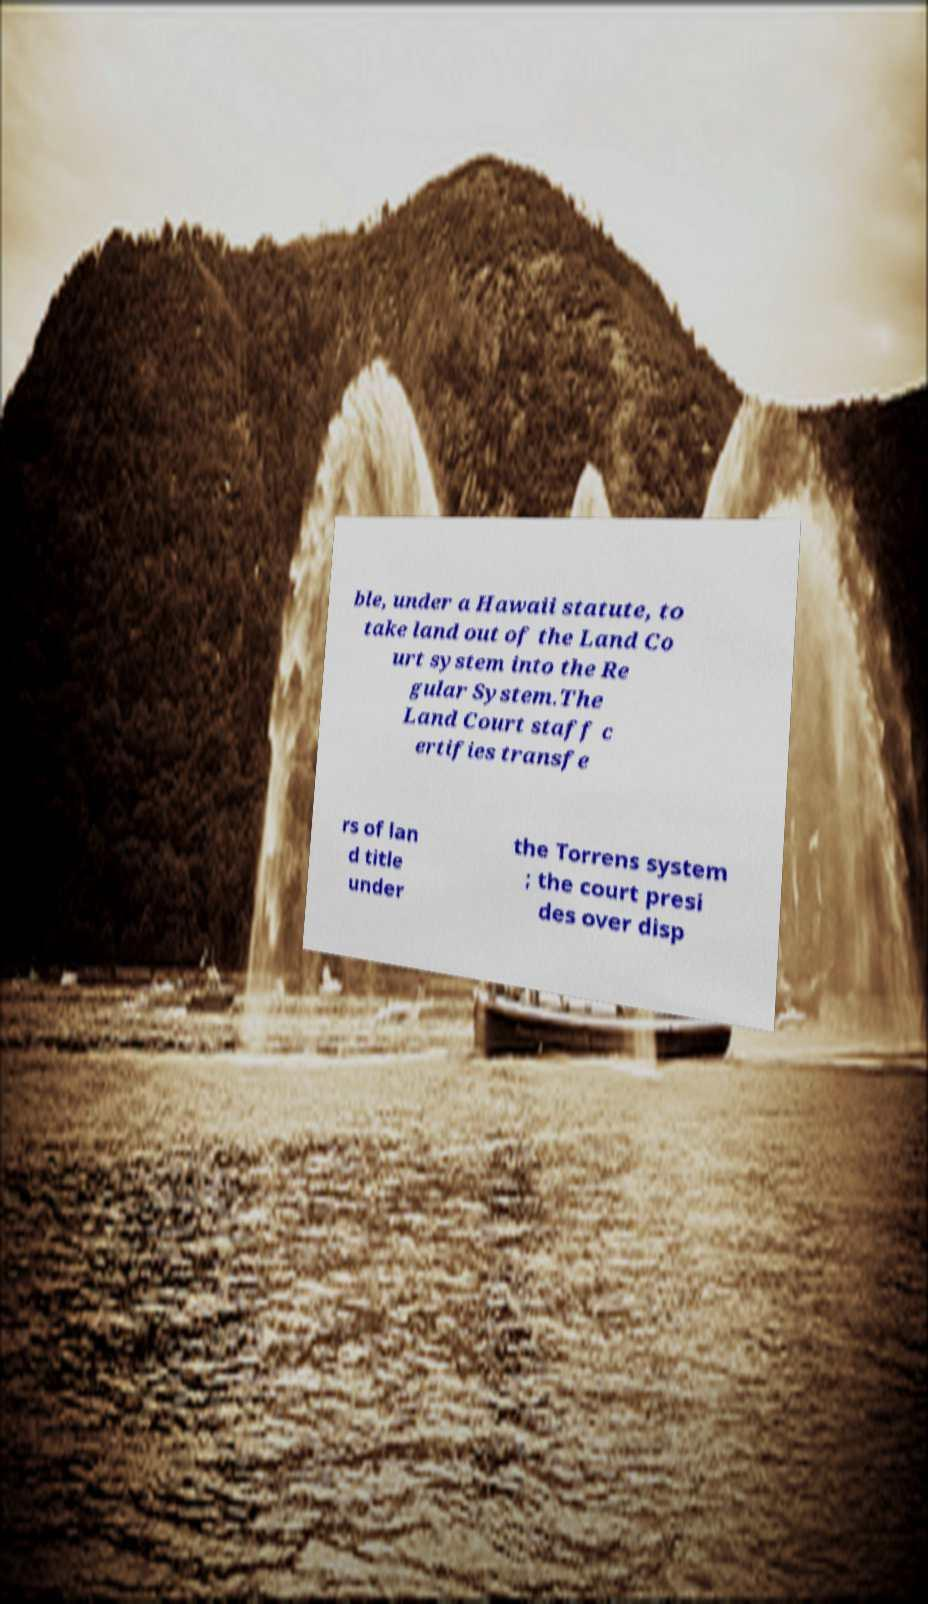I need the written content from this picture converted into text. Can you do that? ble, under a Hawaii statute, to take land out of the Land Co urt system into the Re gular System.The Land Court staff c ertifies transfe rs of lan d title under the Torrens system ; the court presi des over disp 